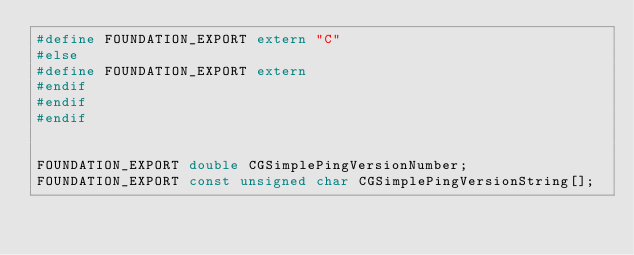Convert code to text. <code><loc_0><loc_0><loc_500><loc_500><_C_>#define FOUNDATION_EXPORT extern "C"
#else
#define FOUNDATION_EXPORT extern
#endif
#endif
#endif


FOUNDATION_EXPORT double CGSimplePingVersionNumber;
FOUNDATION_EXPORT const unsigned char CGSimplePingVersionString[];

</code> 